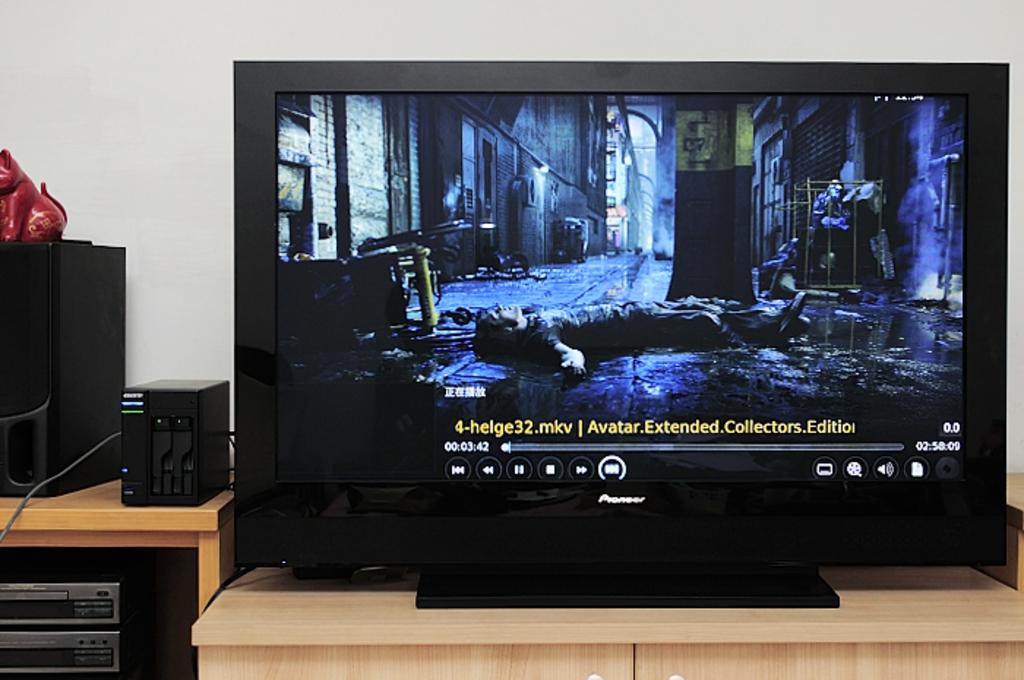<image>
Create a compact narrative representing the image presented. A pioneer television sits on a wooden table.. 